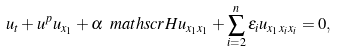<formula> <loc_0><loc_0><loc_500><loc_500>u _ { t } + u ^ { p } u _ { x _ { 1 } } + \alpha \ m a t h s c r { H } u _ { x _ { 1 } x _ { 1 } } + \sum _ { i = 2 } ^ { n } \varepsilon _ { i } u _ { x _ { 1 } x _ { i } x _ { i } } = 0 ,</formula> 